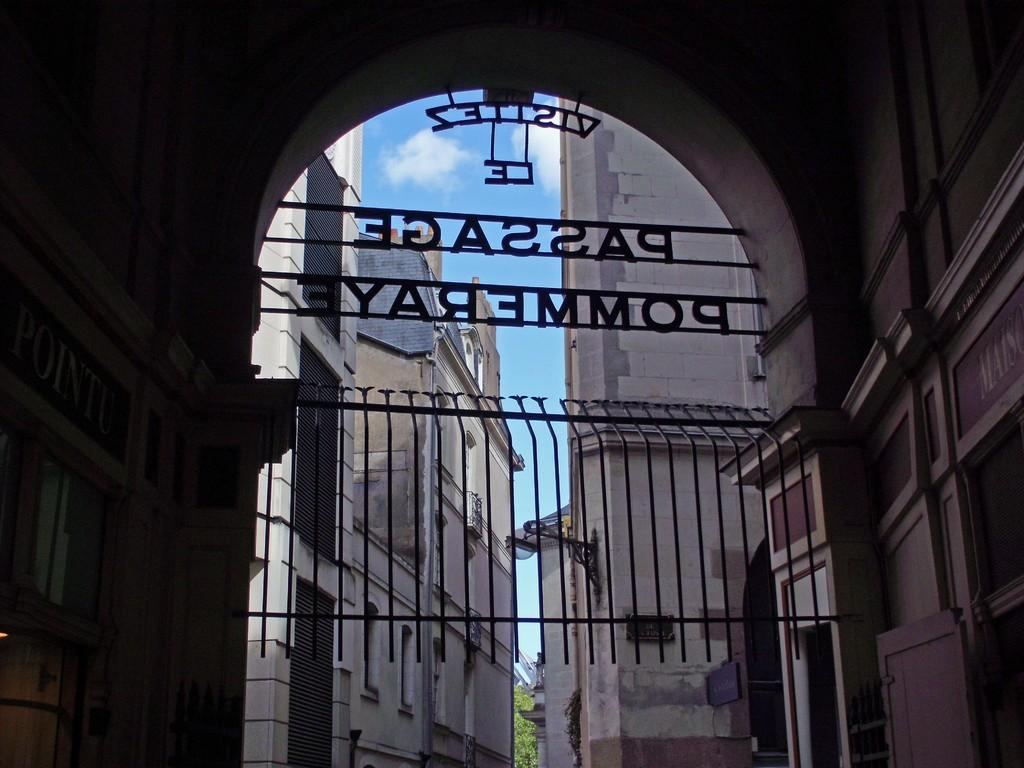What type of structure is present in the image? There is a building in the image. What architectural feature can be seen in the image? There is an arch in the image. What type of barrier is present in the image? There is fencing in the image. What type of man-made structure is present in the image? There is a wall in the image. What type of natural element is present in the image? There is a tree in the image. What part of the natural environment is visible in the image? The sky is visible in the image. What type of credit card is being used to purchase the tree in the image? There is no credit card or purchase activity present in the image; it only features a building, an arch, fencing, a wall, a tree, and the sky. What type of trail can be seen leading to the building in the image? There is no trail present in the image; it only features a building, an arch, fencing, a wall, a tree, and the sky. 